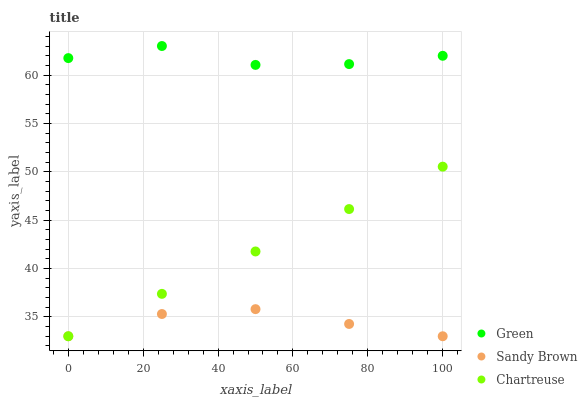Does Sandy Brown have the minimum area under the curve?
Answer yes or no. Yes. Does Green have the maximum area under the curve?
Answer yes or no. Yes. Does Chartreuse have the minimum area under the curve?
Answer yes or no. No. Does Chartreuse have the maximum area under the curve?
Answer yes or no. No. Is Chartreuse the smoothest?
Answer yes or no. Yes. Is Green the roughest?
Answer yes or no. Yes. Is Green the smoothest?
Answer yes or no. No. Is Chartreuse the roughest?
Answer yes or no. No. Does Sandy Brown have the lowest value?
Answer yes or no. Yes. Does Green have the lowest value?
Answer yes or no. No. Does Green have the highest value?
Answer yes or no. Yes. Does Chartreuse have the highest value?
Answer yes or no. No. Is Sandy Brown less than Green?
Answer yes or no. Yes. Is Green greater than Chartreuse?
Answer yes or no. Yes. Does Sandy Brown intersect Chartreuse?
Answer yes or no. Yes. Is Sandy Brown less than Chartreuse?
Answer yes or no. No. Is Sandy Brown greater than Chartreuse?
Answer yes or no. No. Does Sandy Brown intersect Green?
Answer yes or no. No. 